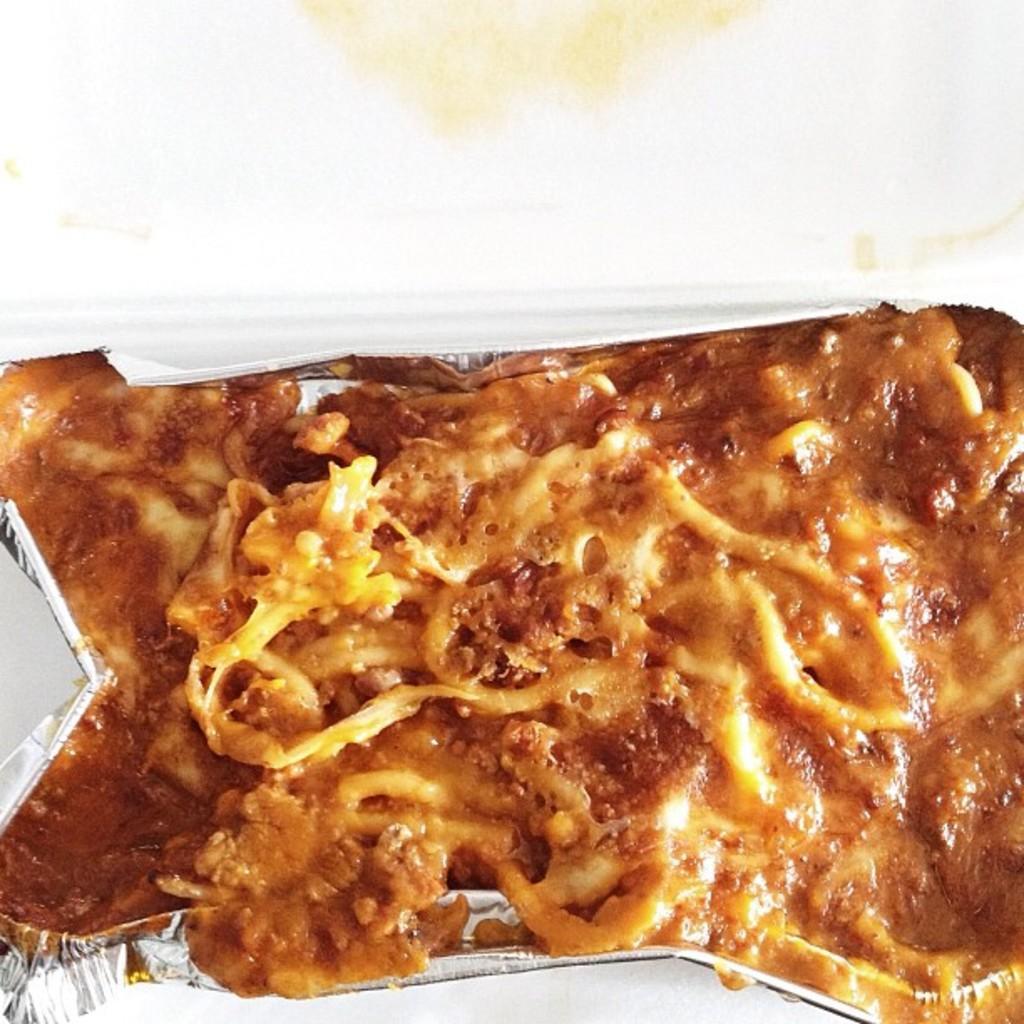How would you summarize this image in a sentence or two? In this picture I can see food in the aluminium foil container and I can see a white color background. 